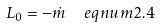Convert formula to latex. <formula><loc_0><loc_0><loc_500><loc_500>L _ { 0 } = - \dot { m } \ \ e q n u m { 2 . 4 }</formula> 